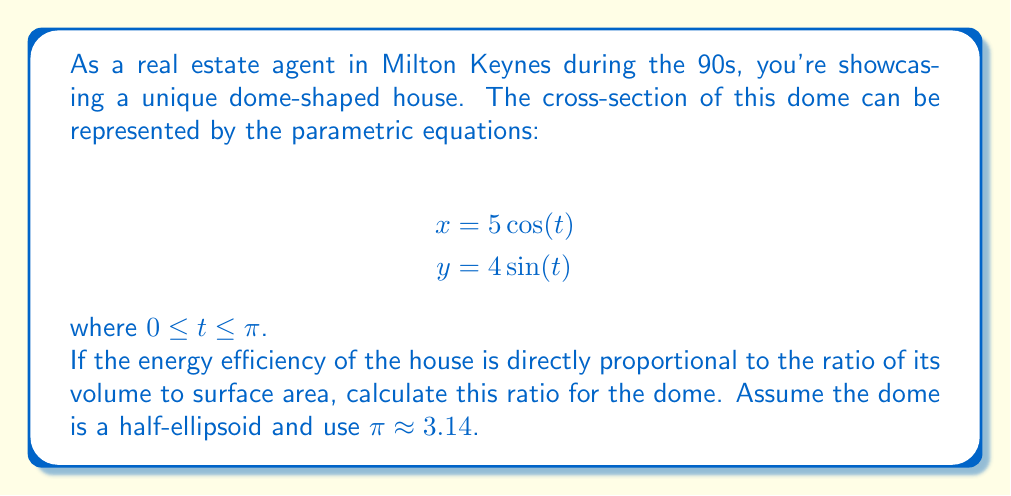Provide a solution to this math problem. Let's approach this step-by-step:

1) The given parametric equations represent an ellipse. The dome is a half-ellipsoid formed by rotating this ellipse around the y-axis.

2) For a half-ellipsoid:
   Volume: $V = \frac{2}{3}\pi a^2b$
   Surface Area: $S = \pi a^2 + \frac{\pi ab}{2}E(\epsilon)$

   Where $a$ is the radius along the x-axis, $b$ is the height along the y-axis, and $E(\epsilon)$ is the complete elliptic integral of the second kind with eccentricity $\epsilon$.

3) From the parametric equations:
   $a = 5$ (coefficient of $\cos(t)$)
   $b = 4$ (coefficient of $\sin(t)$)

4) Calculate the volume:
   $V = \frac{2}{3}\pi (5)^2(4) = \frac{2}{3}\pi(100) \approx 209.33$ cubic units

5) For the surface area, we need to calculate $E(\epsilon)$:
   $\epsilon = \sqrt{1 - \frac{b^2}{a^2}} = \sqrt{1 - \frac{4^2}{5^2}} \approx 0.6$

   $E(0.6) \approx 1.21$ (This can be looked up in tables or calculated numerically)

6) Now calculate the surface area:
   $S = \pi(5)^2 + \frac{\pi(5)(4)}{2}(1.21) \approx 78.5 + 75.63 \approx 154.13$ square units

7) The ratio of volume to surface area is:
   $\frac{V}{S} = \frac{209.33}{154.13} \approx 1.36$ units
Answer: The ratio of volume to surface area for the dome-shaped house is approximately 1.36 units. 